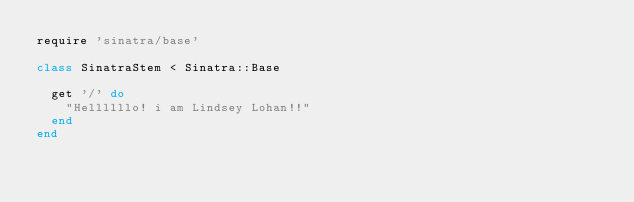<code> <loc_0><loc_0><loc_500><loc_500><_Ruby_>require 'sinatra/base'

class SinatraStem < Sinatra::Base
  
  get '/' do
    "Hellllllo! i am Lindsey Lohan!!"
  end
end

</code> 